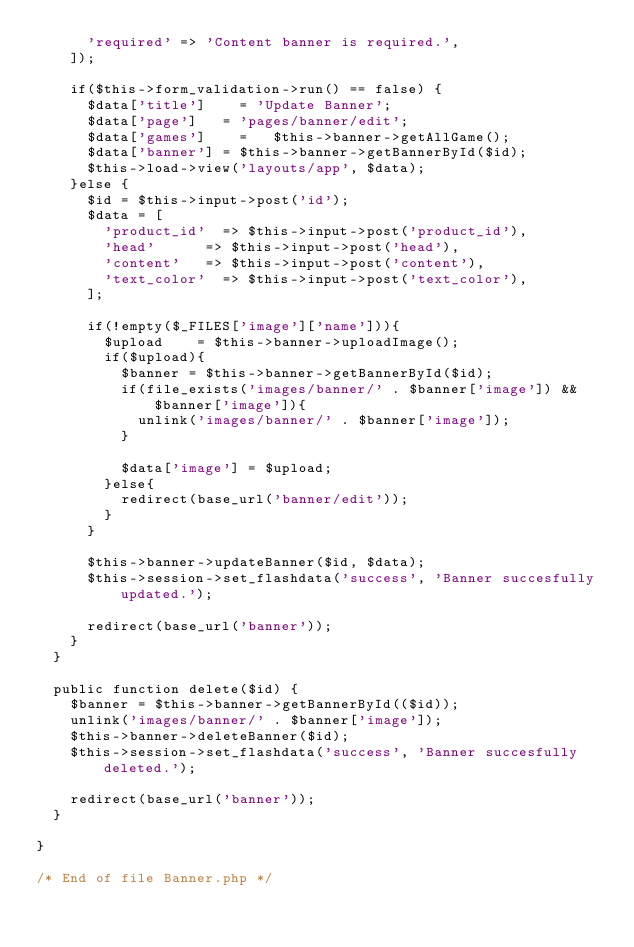<code> <loc_0><loc_0><loc_500><loc_500><_PHP_>			'required' => 'Content banner is required.',
		]);

		if($this->form_validation->run() == false) {
			$data['title']		= 'Update Banner';
			$data['page']		= 'pages/banner/edit';
			$data['games']		= 	$this->banner->getAllGame();	
			$data['banner']	= $this->banner->getBannerById($id);
			$this->load->view('layouts/app', $data);
		}else {
			$id = $this->input->post('id');
			$data = [
				'product_id'	=> $this->input->post('product_id'),
				'head'			=> $this->input->post('head'),
				'content'		=> $this->input->post('content'),
				'text_color'	=> $this->input->post('text_color'),
			];

			if(!empty($_FILES['image']['name'])){
				$upload 	 = $this->banner->uploadImage();
				if($upload){
					$banner = $this->banner->getBannerById($id);
					if(file_exists('images/banner/' . $banner['image']) && $banner['image']){
						unlink('images/banner/' . $banner['image']);
					}
					
					$data['image'] = $upload;
				}else{
					redirect(base_url('banner/edit'));
				}
			}

			$this->banner->updateBanner($id, $data);
			$this->session->set_flashdata('success', 'Banner succesfully updated.');

			redirect(base_url('banner'));
		}
	}

	public function delete($id) {
		$banner = $this->banner->getBannerById(($id));
		unlink('images/banner/' . $banner['image']);
		$this->banner->deleteBanner($id);
		$this->session->set_flashdata('success', 'Banner succesfully deleted.');

		redirect(base_url('banner'));
	}

}

/* End of file Banner.php */
</code> 